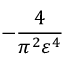Convert formula to latex. <formula><loc_0><loc_0><loc_500><loc_500>- \frac { 4 } { \pi ^ { 2 } \varepsilon ^ { 4 } }</formula> 